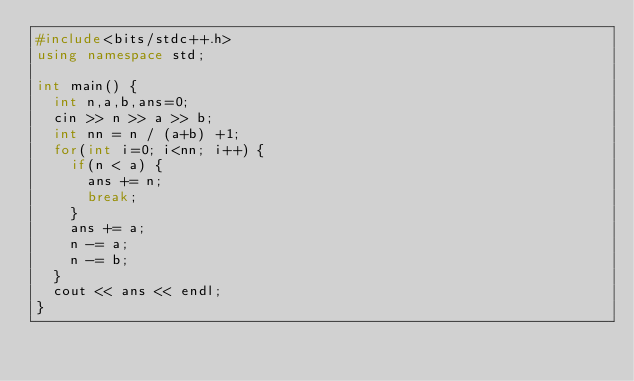<code> <loc_0><loc_0><loc_500><loc_500><_C++_>#include<bits/stdc++.h>
using namespace std;

int main() {
  int n,a,b,ans=0;
  cin >> n >> a >> b;
  int nn = n / (a+b) +1;
  for(int i=0; i<nn; i++) {
    if(n < a) {
      ans += n;
      break;
    }
    ans += a;
    n -= a;
    n -= b;
  }
  cout << ans << endl;
}</code> 